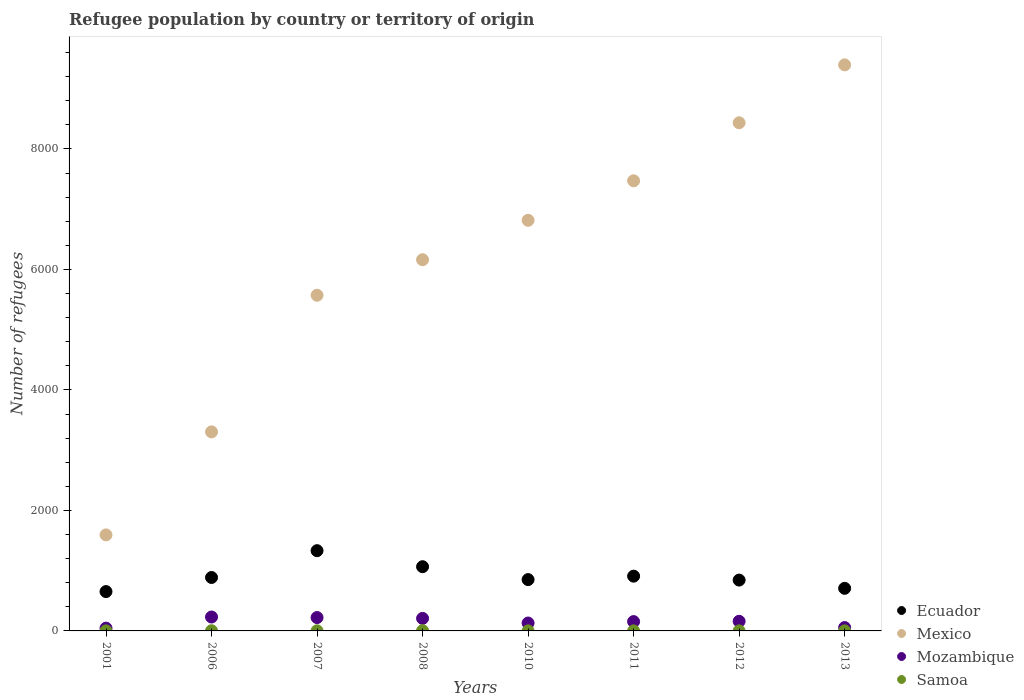What is the number of refugees in Mozambique in 2013?
Provide a succinct answer. 56. Across all years, what is the maximum number of refugees in Mozambique?
Offer a very short reply. 231. Across all years, what is the minimum number of refugees in Mozambique?
Give a very brief answer. 46. In which year was the number of refugees in Ecuador maximum?
Make the answer very short. 2007. In which year was the number of refugees in Samoa minimum?
Offer a terse response. 2001. What is the total number of refugees in Mexico in the graph?
Give a very brief answer. 4.88e+04. What is the difference between the number of refugees in Mexico in 2007 and that in 2013?
Your response must be concise. -3824. What is the difference between the number of refugees in Ecuador in 2013 and the number of refugees in Samoa in 2010?
Make the answer very short. 706. What is the average number of refugees in Ecuador per year?
Keep it short and to the point. 906.25. In the year 2007, what is the difference between the number of refugees in Mozambique and number of refugees in Mexico?
Make the answer very short. -5350. In how many years, is the number of refugees in Mexico greater than 2800?
Make the answer very short. 7. Is the number of refugees in Mexico in 2006 less than that in 2007?
Give a very brief answer. Yes. What is the difference between the highest and the second highest number of refugees in Mexico?
Your response must be concise. 961. What is the difference between the highest and the lowest number of refugees in Ecuador?
Make the answer very short. 679. Is the sum of the number of refugees in Samoa in 2001 and 2007 greater than the maximum number of refugees in Mexico across all years?
Make the answer very short. No. Does the graph contain any zero values?
Offer a very short reply. No. Does the graph contain grids?
Provide a short and direct response. No. How many legend labels are there?
Make the answer very short. 4. How are the legend labels stacked?
Your answer should be compact. Vertical. What is the title of the graph?
Your response must be concise. Refugee population by country or territory of origin. Does "Belarus" appear as one of the legend labels in the graph?
Offer a very short reply. No. What is the label or title of the Y-axis?
Offer a terse response. Number of refugees. What is the Number of refugees in Ecuador in 2001?
Provide a succinct answer. 653. What is the Number of refugees of Mexico in 2001?
Your answer should be compact. 1594. What is the Number of refugees in Mozambique in 2001?
Make the answer very short. 46. What is the Number of refugees in Samoa in 2001?
Provide a succinct answer. 1. What is the Number of refugees in Ecuador in 2006?
Offer a very short reply. 887. What is the Number of refugees of Mexico in 2006?
Provide a short and direct response. 3304. What is the Number of refugees of Mozambique in 2006?
Provide a short and direct response. 231. What is the Number of refugees of Ecuador in 2007?
Provide a short and direct response. 1332. What is the Number of refugees in Mexico in 2007?
Keep it short and to the point. 5572. What is the Number of refugees in Mozambique in 2007?
Provide a short and direct response. 222. What is the Number of refugees in Ecuador in 2008?
Your answer should be compact. 1066. What is the Number of refugees in Mexico in 2008?
Make the answer very short. 6162. What is the Number of refugees in Mozambique in 2008?
Your answer should be very brief. 208. What is the Number of refugees of Samoa in 2008?
Provide a short and direct response. 4. What is the Number of refugees in Ecuador in 2010?
Provide a short and direct response. 852. What is the Number of refugees of Mexico in 2010?
Keep it short and to the point. 6816. What is the Number of refugees of Mozambique in 2010?
Offer a terse response. 131. What is the Number of refugees in Ecuador in 2011?
Offer a terse response. 909. What is the Number of refugees in Mexico in 2011?
Make the answer very short. 7472. What is the Number of refugees of Mozambique in 2011?
Provide a succinct answer. 155. What is the Number of refugees of Samoa in 2011?
Ensure brevity in your answer.  1. What is the Number of refugees of Ecuador in 2012?
Provide a succinct answer. 844. What is the Number of refugees of Mexico in 2012?
Provide a succinct answer. 8435. What is the Number of refugees of Mozambique in 2012?
Your response must be concise. 160. What is the Number of refugees of Samoa in 2012?
Your response must be concise. 1. What is the Number of refugees in Ecuador in 2013?
Make the answer very short. 707. What is the Number of refugees of Mexico in 2013?
Provide a short and direct response. 9396. What is the Number of refugees of Mozambique in 2013?
Give a very brief answer. 56. Across all years, what is the maximum Number of refugees in Ecuador?
Your answer should be very brief. 1332. Across all years, what is the maximum Number of refugees in Mexico?
Your answer should be compact. 9396. Across all years, what is the maximum Number of refugees of Mozambique?
Give a very brief answer. 231. Across all years, what is the minimum Number of refugees of Ecuador?
Your answer should be very brief. 653. Across all years, what is the minimum Number of refugees of Mexico?
Make the answer very short. 1594. Across all years, what is the minimum Number of refugees in Samoa?
Provide a short and direct response. 1. What is the total Number of refugees of Ecuador in the graph?
Offer a terse response. 7250. What is the total Number of refugees in Mexico in the graph?
Provide a succinct answer. 4.88e+04. What is the total Number of refugees in Mozambique in the graph?
Ensure brevity in your answer.  1209. What is the difference between the Number of refugees of Ecuador in 2001 and that in 2006?
Your answer should be compact. -234. What is the difference between the Number of refugees of Mexico in 2001 and that in 2006?
Keep it short and to the point. -1710. What is the difference between the Number of refugees in Mozambique in 2001 and that in 2006?
Give a very brief answer. -185. What is the difference between the Number of refugees in Ecuador in 2001 and that in 2007?
Make the answer very short. -679. What is the difference between the Number of refugees in Mexico in 2001 and that in 2007?
Give a very brief answer. -3978. What is the difference between the Number of refugees in Mozambique in 2001 and that in 2007?
Keep it short and to the point. -176. What is the difference between the Number of refugees in Ecuador in 2001 and that in 2008?
Ensure brevity in your answer.  -413. What is the difference between the Number of refugees of Mexico in 2001 and that in 2008?
Make the answer very short. -4568. What is the difference between the Number of refugees of Mozambique in 2001 and that in 2008?
Keep it short and to the point. -162. What is the difference between the Number of refugees of Samoa in 2001 and that in 2008?
Your response must be concise. -3. What is the difference between the Number of refugees of Ecuador in 2001 and that in 2010?
Make the answer very short. -199. What is the difference between the Number of refugees in Mexico in 2001 and that in 2010?
Give a very brief answer. -5222. What is the difference between the Number of refugees in Mozambique in 2001 and that in 2010?
Your answer should be very brief. -85. What is the difference between the Number of refugees in Ecuador in 2001 and that in 2011?
Provide a short and direct response. -256. What is the difference between the Number of refugees of Mexico in 2001 and that in 2011?
Offer a very short reply. -5878. What is the difference between the Number of refugees in Mozambique in 2001 and that in 2011?
Your answer should be very brief. -109. What is the difference between the Number of refugees in Ecuador in 2001 and that in 2012?
Give a very brief answer. -191. What is the difference between the Number of refugees in Mexico in 2001 and that in 2012?
Your answer should be very brief. -6841. What is the difference between the Number of refugees in Mozambique in 2001 and that in 2012?
Keep it short and to the point. -114. What is the difference between the Number of refugees of Samoa in 2001 and that in 2012?
Give a very brief answer. 0. What is the difference between the Number of refugees of Ecuador in 2001 and that in 2013?
Ensure brevity in your answer.  -54. What is the difference between the Number of refugees in Mexico in 2001 and that in 2013?
Keep it short and to the point. -7802. What is the difference between the Number of refugees of Samoa in 2001 and that in 2013?
Your answer should be compact. 0. What is the difference between the Number of refugees in Ecuador in 2006 and that in 2007?
Keep it short and to the point. -445. What is the difference between the Number of refugees in Mexico in 2006 and that in 2007?
Offer a terse response. -2268. What is the difference between the Number of refugees in Ecuador in 2006 and that in 2008?
Your response must be concise. -179. What is the difference between the Number of refugees of Mexico in 2006 and that in 2008?
Keep it short and to the point. -2858. What is the difference between the Number of refugees in Mozambique in 2006 and that in 2008?
Ensure brevity in your answer.  23. What is the difference between the Number of refugees of Samoa in 2006 and that in 2008?
Give a very brief answer. -1. What is the difference between the Number of refugees of Ecuador in 2006 and that in 2010?
Offer a very short reply. 35. What is the difference between the Number of refugees of Mexico in 2006 and that in 2010?
Provide a short and direct response. -3512. What is the difference between the Number of refugees of Mozambique in 2006 and that in 2010?
Your answer should be compact. 100. What is the difference between the Number of refugees of Ecuador in 2006 and that in 2011?
Your answer should be compact. -22. What is the difference between the Number of refugees in Mexico in 2006 and that in 2011?
Give a very brief answer. -4168. What is the difference between the Number of refugees in Samoa in 2006 and that in 2011?
Ensure brevity in your answer.  2. What is the difference between the Number of refugees of Mexico in 2006 and that in 2012?
Your answer should be very brief. -5131. What is the difference between the Number of refugees of Samoa in 2006 and that in 2012?
Give a very brief answer. 2. What is the difference between the Number of refugees of Ecuador in 2006 and that in 2013?
Offer a very short reply. 180. What is the difference between the Number of refugees in Mexico in 2006 and that in 2013?
Make the answer very short. -6092. What is the difference between the Number of refugees in Mozambique in 2006 and that in 2013?
Make the answer very short. 175. What is the difference between the Number of refugees of Samoa in 2006 and that in 2013?
Make the answer very short. 2. What is the difference between the Number of refugees of Ecuador in 2007 and that in 2008?
Make the answer very short. 266. What is the difference between the Number of refugees of Mexico in 2007 and that in 2008?
Offer a very short reply. -590. What is the difference between the Number of refugees in Mozambique in 2007 and that in 2008?
Give a very brief answer. 14. What is the difference between the Number of refugees in Samoa in 2007 and that in 2008?
Provide a short and direct response. -2. What is the difference between the Number of refugees in Ecuador in 2007 and that in 2010?
Ensure brevity in your answer.  480. What is the difference between the Number of refugees of Mexico in 2007 and that in 2010?
Make the answer very short. -1244. What is the difference between the Number of refugees of Mozambique in 2007 and that in 2010?
Provide a succinct answer. 91. What is the difference between the Number of refugees of Ecuador in 2007 and that in 2011?
Your response must be concise. 423. What is the difference between the Number of refugees of Mexico in 2007 and that in 2011?
Ensure brevity in your answer.  -1900. What is the difference between the Number of refugees of Ecuador in 2007 and that in 2012?
Provide a succinct answer. 488. What is the difference between the Number of refugees of Mexico in 2007 and that in 2012?
Provide a succinct answer. -2863. What is the difference between the Number of refugees in Ecuador in 2007 and that in 2013?
Make the answer very short. 625. What is the difference between the Number of refugees of Mexico in 2007 and that in 2013?
Give a very brief answer. -3824. What is the difference between the Number of refugees of Mozambique in 2007 and that in 2013?
Your response must be concise. 166. What is the difference between the Number of refugees in Samoa in 2007 and that in 2013?
Provide a succinct answer. 1. What is the difference between the Number of refugees of Ecuador in 2008 and that in 2010?
Give a very brief answer. 214. What is the difference between the Number of refugees of Mexico in 2008 and that in 2010?
Your answer should be very brief. -654. What is the difference between the Number of refugees of Mozambique in 2008 and that in 2010?
Make the answer very short. 77. What is the difference between the Number of refugees in Ecuador in 2008 and that in 2011?
Offer a terse response. 157. What is the difference between the Number of refugees in Mexico in 2008 and that in 2011?
Offer a terse response. -1310. What is the difference between the Number of refugees of Ecuador in 2008 and that in 2012?
Provide a short and direct response. 222. What is the difference between the Number of refugees in Mexico in 2008 and that in 2012?
Ensure brevity in your answer.  -2273. What is the difference between the Number of refugees in Mozambique in 2008 and that in 2012?
Your answer should be very brief. 48. What is the difference between the Number of refugees in Samoa in 2008 and that in 2012?
Ensure brevity in your answer.  3. What is the difference between the Number of refugees of Ecuador in 2008 and that in 2013?
Provide a short and direct response. 359. What is the difference between the Number of refugees of Mexico in 2008 and that in 2013?
Your response must be concise. -3234. What is the difference between the Number of refugees in Mozambique in 2008 and that in 2013?
Offer a very short reply. 152. What is the difference between the Number of refugees in Samoa in 2008 and that in 2013?
Provide a succinct answer. 3. What is the difference between the Number of refugees of Ecuador in 2010 and that in 2011?
Your answer should be very brief. -57. What is the difference between the Number of refugees of Mexico in 2010 and that in 2011?
Ensure brevity in your answer.  -656. What is the difference between the Number of refugees of Mozambique in 2010 and that in 2011?
Your answer should be very brief. -24. What is the difference between the Number of refugees in Samoa in 2010 and that in 2011?
Provide a short and direct response. 0. What is the difference between the Number of refugees in Mexico in 2010 and that in 2012?
Your response must be concise. -1619. What is the difference between the Number of refugees in Mozambique in 2010 and that in 2012?
Keep it short and to the point. -29. What is the difference between the Number of refugees in Samoa in 2010 and that in 2012?
Provide a succinct answer. 0. What is the difference between the Number of refugees of Ecuador in 2010 and that in 2013?
Offer a very short reply. 145. What is the difference between the Number of refugees of Mexico in 2010 and that in 2013?
Provide a succinct answer. -2580. What is the difference between the Number of refugees of Mozambique in 2010 and that in 2013?
Offer a very short reply. 75. What is the difference between the Number of refugees in Ecuador in 2011 and that in 2012?
Your response must be concise. 65. What is the difference between the Number of refugees in Mexico in 2011 and that in 2012?
Give a very brief answer. -963. What is the difference between the Number of refugees of Ecuador in 2011 and that in 2013?
Your response must be concise. 202. What is the difference between the Number of refugees in Mexico in 2011 and that in 2013?
Your answer should be very brief. -1924. What is the difference between the Number of refugees in Ecuador in 2012 and that in 2013?
Your answer should be very brief. 137. What is the difference between the Number of refugees of Mexico in 2012 and that in 2013?
Ensure brevity in your answer.  -961. What is the difference between the Number of refugees in Mozambique in 2012 and that in 2013?
Your response must be concise. 104. What is the difference between the Number of refugees of Ecuador in 2001 and the Number of refugees of Mexico in 2006?
Your answer should be compact. -2651. What is the difference between the Number of refugees in Ecuador in 2001 and the Number of refugees in Mozambique in 2006?
Keep it short and to the point. 422. What is the difference between the Number of refugees of Ecuador in 2001 and the Number of refugees of Samoa in 2006?
Ensure brevity in your answer.  650. What is the difference between the Number of refugees in Mexico in 2001 and the Number of refugees in Mozambique in 2006?
Give a very brief answer. 1363. What is the difference between the Number of refugees in Mexico in 2001 and the Number of refugees in Samoa in 2006?
Provide a short and direct response. 1591. What is the difference between the Number of refugees of Mozambique in 2001 and the Number of refugees of Samoa in 2006?
Your answer should be very brief. 43. What is the difference between the Number of refugees in Ecuador in 2001 and the Number of refugees in Mexico in 2007?
Your answer should be compact. -4919. What is the difference between the Number of refugees in Ecuador in 2001 and the Number of refugees in Mozambique in 2007?
Offer a very short reply. 431. What is the difference between the Number of refugees of Ecuador in 2001 and the Number of refugees of Samoa in 2007?
Offer a very short reply. 651. What is the difference between the Number of refugees in Mexico in 2001 and the Number of refugees in Mozambique in 2007?
Your response must be concise. 1372. What is the difference between the Number of refugees of Mexico in 2001 and the Number of refugees of Samoa in 2007?
Provide a succinct answer. 1592. What is the difference between the Number of refugees of Mozambique in 2001 and the Number of refugees of Samoa in 2007?
Your response must be concise. 44. What is the difference between the Number of refugees in Ecuador in 2001 and the Number of refugees in Mexico in 2008?
Your answer should be compact. -5509. What is the difference between the Number of refugees in Ecuador in 2001 and the Number of refugees in Mozambique in 2008?
Ensure brevity in your answer.  445. What is the difference between the Number of refugees in Ecuador in 2001 and the Number of refugees in Samoa in 2008?
Your response must be concise. 649. What is the difference between the Number of refugees of Mexico in 2001 and the Number of refugees of Mozambique in 2008?
Provide a succinct answer. 1386. What is the difference between the Number of refugees in Mexico in 2001 and the Number of refugees in Samoa in 2008?
Your answer should be very brief. 1590. What is the difference between the Number of refugees in Mozambique in 2001 and the Number of refugees in Samoa in 2008?
Keep it short and to the point. 42. What is the difference between the Number of refugees in Ecuador in 2001 and the Number of refugees in Mexico in 2010?
Your answer should be very brief. -6163. What is the difference between the Number of refugees of Ecuador in 2001 and the Number of refugees of Mozambique in 2010?
Give a very brief answer. 522. What is the difference between the Number of refugees in Ecuador in 2001 and the Number of refugees in Samoa in 2010?
Provide a succinct answer. 652. What is the difference between the Number of refugees in Mexico in 2001 and the Number of refugees in Mozambique in 2010?
Offer a very short reply. 1463. What is the difference between the Number of refugees of Mexico in 2001 and the Number of refugees of Samoa in 2010?
Your answer should be compact. 1593. What is the difference between the Number of refugees of Ecuador in 2001 and the Number of refugees of Mexico in 2011?
Offer a terse response. -6819. What is the difference between the Number of refugees of Ecuador in 2001 and the Number of refugees of Mozambique in 2011?
Ensure brevity in your answer.  498. What is the difference between the Number of refugees of Ecuador in 2001 and the Number of refugees of Samoa in 2011?
Your answer should be compact. 652. What is the difference between the Number of refugees in Mexico in 2001 and the Number of refugees in Mozambique in 2011?
Offer a very short reply. 1439. What is the difference between the Number of refugees of Mexico in 2001 and the Number of refugees of Samoa in 2011?
Your response must be concise. 1593. What is the difference between the Number of refugees of Mozambique in 2001 and the Number of refugees of Samoa in 2011?
Provide a succinct answer. 45. What is the difference between the Number of refugees in Ecuador in 2001 and the Number of refugees in Mexico in 2012?
Offer a very short reply. -7782. What is the difference between the Number of refugees in Ecuador in 2001 and the Number of refugees in Mozambique in 2012?
Offer a terse response. 493. What is the difference between the Number of refugees of Ecuador in 2001 and the Number of refugees of Samoa in 2012?
Ensure brevity in your answer.  652. What is the difference between the Number of refugees in Mexico in 2001 and the Number of refugees in Mozambique in 2012?
Your response must be concise. 1434. What is the difference between the Number of refugees of Mexico in 2001 and the Number of refugees of Samoa in 2012?
Your answer should be very brief. 1593. What is the difference between the Number of refugees of Ecuador in 2001 and the Number of refugees of Mexico in 2013?
Provide a succinct answer. -8743. What is the difference between the Number of refugees in Ecuador in 2001 and the Number of refugees in Mozambique in 2013?
Provide a succinct answer. 597. What is the difference between the Number of refugees in Ecuador in 2001 and the Number of refugees in Samoa in 2013?
Your answer should be compact. 652. What is the difference between the Number of refugees of Mexico in 2001 and the Number of refugees of Mozambique in 2013?
Provide a short and direct response. 1538. What is the difference between the Number of refugees of Mexico in 2001 and the Number of refugees of Samoa in 2013?
Your answer should be very brief. 1593. What is the difference between the Number of refugees in Ecuador in 2006 and the Number of refugees in Mexico in 2007?
Keep it short and to the point. -4685. What is the difference between the Number of refugees of Ecuador in 2006 and the Number of refugees of Mozambique in 2007?
Give a very brief answer. 665. What is the difference between the Number of refugees in Ecuador in 2006 and the Number of refugees in Samoa in 2007?
Offer a very short reply. 885. What is the difference between the Number of refugees of Mexico in 2006 and the Number of refugees of Mozambique in 2007?
Offer a very short reply. 3082. What is the difference between the Number of refugees in Mexico in 2006 and the Number of refugees in Samoa in 2007?
Provide a succinct answer. 3302. What is the difference between the Number of refugees of Mozambique in 2006 and the Number of refugees of Samoa in 2007?
Keep it short and to the point. 229. What is the difference between the Number of refugees in Ecuador in 2006 and the Number of refugees in Mexico in 2008?
Provide a short and direct response. -5275. What is the difference between the Number of refugees in Ecuador in 2006 and the Number of refugees in Mozambique in 2008?
Your response must be concise. 679. What is the difference between the Number of refugees in Ecuador in 2006 and the Number of refugees in Samoa in 2008?
Give a very brief answer. 883. What is the difference between the Number of refugees in Mexico in 2006 and the Number of refugees in Mozambique in 2008?
Your answer should be compact. 3096. What is the difference between the Number of refugees in Mexico in 2006 and the Number of refugees in Samoa in 2008?
Ensure brevity in your answer.  3300. What is the difference between the Number of refugees of Mozambique in 2006 and the Number of refugees of Samoa in 2008?
Give a very brief answer. 227. What is the difference between the Number of refugees of Ecuador in 2006 and the Number of refugees of Mexico in 2010?
Make the answer very short. -5929. What is the difference between the Number of refugees of Ecuador in 2006 and the Number of refugees of Mozambique in 2010?
Offer a very short reply. 756. What is the difference between the Number of refugees in Ecuador in 2006 and the Number of refugees in Samoa in 2010?
Offer a terse response. 886. What is the difference between the Number of refugees of Mexico in 2006 and the Number of refugees of Mozambique in 2010?
Provide a succinct answer. 3173. What is the difference between the Number of refugees in Mexico in 2006 and the Number of refugees in Samoa in 2010?
Keep it short and to the point. 3303. What is the difference between the Number of refugees of Mozambique in 2006 and the Number of refugees of Samoa in 2010?
Give a very brief answer. 230. What is the difference between the Number of refugees in Ecuador in 2006 and the Number of refugees in Mexico in 2011?
Your answer should be very brief. -6585. What is the difference between the Number of refugees of Ecuador in 2006 and the Number of refugees of Mozambique in 2011?
Offer a terse response. 732. What is the difference between the Number of refugees in Ecuador in 2006 and the Number of refugees in Samoa in 2011?
Your response must be concise. 886. What is the difference between the Number of refugees in Mexico in 2006 and the Number of refugees in Mozambique in 2011?
Your answer should be compact. 3149. What is the difference between the Number of refugees of Mexico in 2006 and the Number of refugees of Samoa in 2011?
Keep it short and to the point. 3303. What is the difference between the Number of refugees of Mozambique in 2006 and the Number of refugees of Samoa in 2011?
Offer a very short reply. 230. What is the difference between the Number of refugees in Ecuador in 2006 and the Number of refugees in Mexico in 2012?
Provide a short and direct response. -7548. What is the difference between the Number of refugees of Ecuador in 2006 and the Number of refugees of Mozambique in 2012?
Provide a succinct answer. 727. What is the difference between the Number of refugees in Ecuador in 2006 and the Number of refugees in Samoa in 2012?
Offer a very short reply. 886. What is the difference between the Number of refugees in Mexico in 2006 and the Number of refugees in Mozambique in 2012?
Make the answer very short. 3144. What is the difference between the Number of refugees in Mexico in 2006 and the Number of refugees in Samoa in 2012?
Provide a succinct answer. 3303. What is the difference between the Number of refugees of Mozambique in 2006 and the Number of refugees of Samoa in 2012?
Give a very brief answer. 230. What is the difference between the Number of refugees of Ecuador in 2006 and the Number of refugees of Mexico in 2013?
Your response must be concise. -8509. What is the difference between the Number of refugees of Ecuador in 2006 and the Number of refugees of Mozambique in 2013?
Keep it short and to the point. 831. What is the difference between the Number of refugees in Ecuador in 2006 and the Number of refugees in Samoa in 2013?
Provide a succinct answer. 886. What is the difference between the Number of refugees in Mexico in 2006 and the Number of refugees in Mozambique in 2013?
Provide a succinct answer. 3248. What is the difference between the Number of refugees of Mexico in 2006 and the Number of refugees of Samoa in 2013?
Provide a succinct answer. 3303. What is the difference between the Number of refugees of Mozambique in 2006 and the Number of refugees of Samoa in 2013?
Your answer should be very brief. 230. What is the difference between the Number of refugees in Ecuador in 2007 and the Number of refugees in Mexico in 2008?
Provide a short and direct response. -4830. What is the difference between the Number of refugees in Ecuador in 2007 and the Number of refugees in Mozambique in 2008?
Your response must be concise. 1124. What is the difference between the Number of refugees of Ecuador in 2007 and the Number of refugees of Samoa in 2008?
Give a very brief answer. 1328. What is the difference between the Number of refugees of Mexico in 2007 and the Number of refugees of Mozambique in 2008?
Ensure brevity in your answer.  5364. What is the difference between the Number of refugees in Mexico in 2007 and the Number of refugees in Samoa in 2008?
Your answer should be very brief. 5568. What is the difference between the Number of refugees in Mozambique in 2007 and the Number of refugees in Samoa in 2008?
Make the answer very short. 218. What is the difference between the Number of refugees in Ecuador in 2007 and the Number of refugees in Mexico in 2010?
Provide a succinct answer. -5484. What is the difference between the Number of refugees in Ecuador in 2007 and the Number of refugees in Mozambique in 2010?
Offer a very short reply. 1201. What is the difference between the Number of refugees in Ecuador in 2007 and the Number of refugees in Samoa in 2010?
Give a very brief answer. 1331. What is the difference between the Number of refugees in Mexico in 2007 and the Number of refugees in Mozambique in 2010?
Provide a short and direct response. 5441. What is the difference between the Number of refugees in Mexico in 2007 and the Number of refugees in Samoa in 2010?
Provide a succinct answer. 5571. What is the difference between the Number of refugees of Mozambique in 2007 and the Number of refugees of Samoa in 2010?
Your answer should be compact. 221. What is the difference between the Number of refugees of Ecuador in 2007 and the Number of refugees of Mexico in 2011?
Keep it short and to the point. -6140. What is the difference between the Number of refugees of Ecuador in 2007 and the Number of refugees of Mozambique in 2011?
Provide a succinct answer. 1177. What is the difference between the Number of refugees in Ecuador in 2007 and the Number of refugees in Samoa in 2011?
Ensure brevity in your answer.  1331. What is the difference between the Number of refugees in Mexico in 2007 and the Number of refugees in Mozambique in 2011?
Give a very brief answer. 5417. What is the difference between the Number of refugees of Mexico in 2007 and the Number of refugees of Samoa in 2011?
Your response must be concise. 5571. What is the difference between the Number of refugees of Mozambique in 2007 and the Number of refugees of Samoa in 2011?
Provide a short and direct response. 221. What is the difference between the Number of refugees in Ecuador in 2007 and the Number of refugees in Mexico in 2012?
Your answer should be compact. -7103. What is the difference between the Number of refugees of Ecuador in 2007 and the Number of refugees of Mozambique in 2012?
Your response must be concise. 1172. What is the difference between the Number of refugees in Ecuador in 2007 and the Number of refugees in Samoa in 2012?
Provide a short and direct response. 1331. What is the difference between the Number of refugees of Mexico in 2007 and the Number of refugees of Mozambique in 2012?
Your answer should be very brief. 5412. What is the difference between the Number of refugees of Mexico in 2007 and the Number of refugees of Samoa in 2012?
Provide a succinct answer. 5571. What is the difference between the Number of refugees in Mozambique in 2007 and the Number of refugees in Samoa in 2012?
Your answer should be compact. 221. What is the difference between the Number of refugees of Ecuador in 2007 and the Number of refugees of Mexico in 2013?
Offer a terse response. -8064. What is the difference between the Number of refugees of Ecuador in 2007 and the Number of refugees of Mozambique in 2013?
Provide a succinct answer. 1276. What is the difference between the Number of refugees of Ecuador in 2007 and the Number of refugees of Samoa in 2013?
Offer a very short reply. 1331. What is the difference between the Number of refugees in Mexico in 2007 and the Number of refugees in Mozambique in 2013?
Your answer should be very brief. 5516. What is the difference between the Number of refugees of Mexico in 2007 and the Number of refugees of Samoa in 2013?
Provide a succinct answer. 5571. What is the difference between the Number of refugees of Mozambique in 2007 and the Number of refugees of Samoa in 2013?
Give a very brief answer. 221. What is the difference between the Number of refugees in Ecuador in 2008 and the Number of refugees in Mexico in 2010?
Provide a succinct answer. -5750. What is the difference between the Number of refugees of Ecuador in 2008 and the Number of refugees of Mozambique in 2010?
Your answer should be compact. 935. What is the difference between the Number of refugees of Ecuador in 2008 and the Number of refugees of Samoa in 2010?
Ensure brevity in your answer.  1065. What is the difference between the Number of refugees in Mexico in 2008 and the Number of refugees in Mozambique in 2010?
Your response must be concise. 6031. What is the difference between the Number of refugees of Mexico in 2008 and the Number of refugees of Samoa in 2010?
Offer a terse response. 6161. What is the difference between the Number of refugees of Mozambique in 2008 and the Number of refugees of Samoa in 2010?
Ensure brevity in your answer.  207. What is the difference between the Number of refugees in Ecuador in 2008 and the Number of refugees in Mexico in 2011?
Ensure brevity in your answer.  -6406. What is the difference between the Number of refugees of Ecuador in 2008 and the Number of refugees of Mozambique in 2011?
Offer a very short reply. 911. What is the difference between the Number of refugees of Ecuador in 2008 and the Number of refugees of Samoa in 2011?
Provide a succinct answer. 1065. What is the difference between the Number of refugees in Mexico in 2008 and the Number of refugees in Mozambique in 2011?
Keep it short and to the point. 6007. What is the difference between the Number of refugees in Mexico in 2008 and the Number of refugees in Samoa in 2011?
Offer a very short reply. 6161. What is the difference between the Number of refugees in Mozambique in 2008 and the Number of refugees in Samoa in 2011?
Your response must be concise. 207. What is the difference between the Number of refugees of Ecuador in 2008 and the Number of refugees of Mexico in 2012?
Ensure brevity in your answer.  -7369. What is the difference between the Number of refugees of Ecuador in 2008 and the Number of refugees of Mozambique in 2012?
Provide a short and direct response. 906. What is the difference between the Number of refugees of Ecuador in 2008 and the Number of refugees of Samoa in 2012?
Ensure brevity in your answer.  1065. What is the difference between the Number of refugees of Mexico in 2008 and the Number of refugees of Mozambique in 2012?
Provide a succinct answer. 6002. What is the difference between the Number of refugees of Mexico in 2008 and the Number of refugees of Samoa in 2012?
Offer a terse response. 6161. What is the difference between the Number of refugees in Mozambique in 2008 and the Number of refugees in Samoa in 2012?
Give a very brief answer. 207. What is the difference between the Number of refugees in Ecuador in 2008 and the Number of refugees in Mexico in 2013?
Offer a terse response. -8330. What is the difference between the Number of refugees of Ecuador in 2008 and the Number of refugees of Mozambique in 2013?
Provide a succinct answer. 1010. What is the difference between the Number of refugees of Ecuador in 2008 and the Number of refugees of Samoa in 2013?
Your answer should be compact. 1065. What is the difference between the Number of refugees of Mexico in 2008 and the Number of refugees of Mozambique in 2013?
Your answer should be compact. 6106. What is the difference between the Number of refugees of Mexico in 2008 and the Number of refugees of Samoa in 2013?
Your answer should be compact. 6161. What is the difference between the Number of refugees of Mozambique in 2008 and the Number of refugees of Samoa in 2013?
Offer a terse response. 207. What is the difference between the Number of refugees in Ecuador in 2010 and the Number of refugees in Mexico in 2011?
Provide a short and direct response. -6620. What is the difference between the Number of refugees in Ecuador in 2010 and the Number of refugees in Mozambique in 2011?
Your answer should be compact. 697. What is the difference between the Number of refugees of Ecuador in 2010 and the Number of refugees of Samoa in 2011?
Offer a terse response. 851. What is the difference between the Number of refugees of Mexico in 2010 and the Number of refugees of Mozambique in 2011?
Your response must be concise. 6661. What is the difference between the Number of refugees in Mexico in 2010 and the Number of refugees in Samoa in 2011?
Make the answer very short. 6815. What is the difference between the Number of refugees in Mozambique in 2010 and the Number of refugees in Samoa in 2011?
Make the answer very short. 130. What is the difference between the Number of refugees in Ecuador in 2010 and the Number of refugees in Mexico in 2012?
Ensure brevity in your answer.  -7583. What is the difference between the Number of refugees in Ecuador in 2010 and the Number of refugees in Mozambique in 2012?
Make the answer very short. 692. What is the difference between the Number of refugees in Ecuador in 2010 and the Number of refugees in Samoa in 2012?
Provide a succinct answer. 851. What is the difference between the Number of refugees of Mexico in 2010 and the Number of refugees of Mozambique in 2012?
Provide a succinct answer. 6656. What is the difference between the Number of refugees of Mexico in 2010 and the Number of refugees of Samoa in 2012?
Your answer should be very brief. 6815. What is the difference between the Number of refugees of Mozambique in 2010 and the Number of refugees of Samoa in 2012?
Ensure brevity in your answer.  130. What is the difference between the Number of refugees of Ecuador in 2010 and the Number of refugees of Mexico in 2013?
Keep it short and to the point. -8544. What is the difference between the Number of refugees in Ecuador in 2010 and the Number of refugees in Mozambique in 2013?
Provide a succinct answer. 796. What is the difference between the Number of refugees of Ecuador in 2010 and the Number of refugees of Samoa in 2013?
Ensure brevity in your answer.  851. What is the difference between the Number of refugees in Mexico in 2010 and the Number of refugees in Mozambique in 2013?
Ensure brevity in your answer.  6760. What is the difference between the Number of refugees in Mexico in 2010 and the Number of refugees in Samoa in 2013?
Make the answer very short. 6815. What is the difference between the Number of refugees in Mozambique in 2010 and the Number of refugees in Samoa in 2013?
Your response must be concise. 130. What is the difference between the Number of refugees of Ecuador in 2011 and the Number of refugees of Mexico in 2012?
Offer a very short reply. -7526. What is the difference between the Number of refugees in Ecuador in 2011 and the Number of refugees in Mozambique in 2012?
Offer a terse response. 749. What is the difference between the Number of refugees of Ecuador in 2011 and the Number of refugees of Samoa in 2012?
Offer a terse response. 908. What is the difference between the Number of refugees of Mexico in 2011 and the Number of refugees of Mozambique in 2012?
Offer a very short reply. 7312. What is the difference between the Number of refugees of Mexico in 2011 and the Number of refugees of Samoa in 2012?
Provide a short and direct response. 7471. What is the difference between the Number of refugees in Mozambique in 2011 and the Number of refugees in Samoa in 2012?
Offer a very short reply. 154. What is the difference between the Number of refugees in Ecuador in 2011 and the Number of refugees in Mexico in 2013?
Make the answer very short. -8487. What is the difference between the Number of refugees of Ecuador in 2011 and the Number of refugees of Mozambique in 2013?
Provide a short and direct response. 853. What is the difference between the Number of refugees in Ecuador in 2011 and the Number of refugees in Samoa in 2013?
Your response must be concise. 908. What is the difference between the Number of refugees in Mexico in 2011 and the Number of refugees in Mozambique in 2013?
Make the answer very short. 7416. What is the difference between the Number of refugees of Mexico in 2011 and the Number of refugees of Samoa in 2013?
Provide a short and direct response. 7471. What is the difference between the Number of refugees of Mozambique in 2011 and the Number of refugees of Samoa in 2013?
Offer a terse response. 154. What is the difference between the Number of refugees in Ecuador in 2012 and the Number of refugees in Mexico in 2013?
Your response must be concise. -8552. What is the difference between the Number of refugees of Ecuador in 2012 and the Number of refugees of Mozambique in 2013?
Your answer should be very brief. 788. What is the difference between the Number of refugees in Ecuador in 2012 and the Number of refugees in Samoa in 2013?
Make the answer very short. 843. What is the difference between the Number of refugees of Mexico in 2012 and the Number of refugees of Mozambique in 2013?
Your answer should be very brief. 8379. What is the difference between the Number of refugees of Mexico in 2012 and the Number of refugees of Samoa in 2013?
Your response must be concise. 8434. What is the difference between the Number of refugees in Mozambique in 2012 and the Number of refugees in Samoa in 2013?
Offer a terse response. 159. What is the average Number of refugees of Ecuador per year?
Ensure brevity in your answer.  906.25. What is the average Number of refugees of Mexico per year?
Offer a very short reply. 6093.88. What is the average Number of refugees in Mozambique per year?
Ensure brevity in your answer.  151.12. In the year 2001, what is the difference between the Number of refugees in Ecuador and Number of refugees in Mexico?
Your response must be concise. -941. In the year 2001, what is the difference between the Number of refugees in Ecuador and Number of refugees in Mozambique?
Your response must be concise. 607. In the year 2001, what is the difference between the Number of refugees in Ecuador and Number of refugees in Samoa?
Ensure brevity in your answer.  652. In the year 2001, what is the difference between the Number of refugees in Mexico and Number of refugees in Mozambique?
Ensure brevity in your answer.  1548. In the year 2001, what is the difference between the Number of refugees in Mexico and Number of refugees in Samoa?
Your response must be concise. 1593. In the year 2001, what is the difference between the Number of refugees in Mozambique and Number of refugees in Samoa?
Make the answer very short. 45. In the year 2006, what is the difference between the Number of refugees of Ecuador and Number of refugees of Mexico?
Give a very brief answer. -2417. In the year 2006, what is the difference between the Number of refugees in Ecuador and Number of refugees in Mozambique?
Your answer should be compact. 656. In the year 2006, what is the difference between the Number of refugees of Ecuador and Number of refugees of Samoa?
Offer a terse response. 884. In the year 2006, what is the difference between the Number of refugees of Mexico and Number of refugees of Mozambique?
Provide a short and direct response. 3073. In the year 2006, what is the difference between the Number of refugees in Mexico and Number of refugees in Samoa?
Your answer should be compact. 3301. In the year 2006, what is the difference between the Number of refugees of Mozambique and Number of refugees of Samoa?
Ensure brevity in your answer.  228. In the year 2007, what is the difference between the Number of refugees in Ecuador and Number of refugees in Mexico?
Offer a very short reply. -4240. In the year 2007, what is the difference between the Number of refugees of Ecuador and Number of refugees of Mozambique?
Give a very brief answer. 1110. In the year 2007, what is the difference between the Number of refugees in Ecuador and Number of refugees in Samoa?
Offer a terse response. 1330. In the year 2007, what is the difference between the Number of refugees of Mexico and Number of refugees of Mozambique?
Offer a terse response. 5350. In the year 2007, what is the difference between the Number of refugees in Mexico and Number of refugees in Samoa?
Make the answer very short. 5570. In the year 2007, what is the difference between the Number of refugees in Mozambique and Number of refugees in Samoa?
Offer a terse response. 220. In the year 2008, what is the difference between the Number of refugees of Ecuador and Number of refugees of Mexico?
Provide a succinct answer. -5096. In the year 2008, what is the difference between the Number of refugees of Ecuador and Number of refugees of Mozambique?
Offer a terse response. 858. In the year 2008, what is the difference between the Number of refugees of Ecuador and Number of refugees of Samoa?
Offer a very short reply. 1062. In the year 2008, what is the difference between the Number of refugees of Mexico and Number of refugees of Mozambique?
Keep it short and to the point. 5954. In the year 2008, what is the difference between the Number of refugees in Mexico and Number of refugees in Samoa?
Your response must be concise. 6158. In the year 2008, what is the difference between the Number of refugees of Mozambique and Number of refugees of Samoa?
Your answer should be very brief. 204. In the year 2010, what is the difference between the Number of refugees in Ecuador and Number of refugees in Mexico?
Provide a short and direct response. -5964. In the year 2010, what is the difference between the Number of refugees of Ecuador and Number of refugees of Mozambique?
Provide a short and direct response. 721. In the year 2010, what is the difference between the Number of refugees in Ecuador and Number of refugees in Samoa?
Ensure brevity in your answer.  851. In the year 2010, what is the difference between the Number of refugees of Mexico and Number of refugees of Mozambique?
Offer a terse response. 6685. In the year 2010, what is the difference between the Number of refugees in Mexico and Number of refugees in Samoa?
Your answer should be compact. 6815. In the year 2010, what is the difference between the Number of refugees in Mozambique and Number of refugees in Samoa?
Provide a succinct answer. 130. In the year 2011, what is the difference between the Number of refugees in Ecuador and Number of refugees in Mexico?
Offer a terse response. -6563. In the year 2011, what is the difference between the Number of refugees of Ecuador and Number of refugees of Mozambique?
Your answer should be very brief. 754. In the year 2011, what is the difference between the Number of refugees in Ecuador and Number of refugees in Samoa?
Keep it short and to the point. 908. In the year 2011, what is the difference between the Number of refugees of Mexico and Number of refugees of Mozambique?
Provide a succinct answer. 7317. In the year 2011, what is the difference between the Number of refugees in Mexico and Number of refugees in Samoa?
Your answer should be compact. 7471. In the year 2011, what is the difference between the Number of refugees of Mozambique and Number of refugees of Samoa?
Keep it short and to the point. 154. In the year 2012, what is the difference between the Number of refugees of Ecuador and Number of refugees of Mexico?
Provide a short and direct response. -7591. In the year 2012, what is the difference between the Number of refugees of Ecuador and Number of refugees of Mozambique?
Offer a very short reply. 684. In the year 2012, what is the difference between the Number of refugees of Ecuador and Number of refugees of Samoa?
Offer a very short reply. 843. In the year 2012, what is the difference between the Number of refugees in Mexico and Number of refugees in Mozambique?
Your answer should be very brief. 8275. In the year 2012, what is the difference between the Number of refugees of Mexico and Number of refugees of Samoa?
Provide a succinct answer. 8434. In the year 2012, what is the difference between the Number of refugees in Mozambique and Number of refugees in Samoa?
Offer a terse response. 159. In the year 2013, what is the difference between the Number of refugees in Ecuador and Number of refugees in Mexico?
Ensure brevity in your answer.  -8689. In the year 2013, what is the difference between the Number of refugees in Ecuador and Number of refugees in Mozambique?
Keep it short and to the point. 651. In the year 2013, what is the difference between the Number of refugees of Ecuador and Number of refugees of Samoa?
Offer a terse response. 706. In the year 2013, what is the difference between the Number of refugees in Mexico and Number of refugees in Mozambique?
Provide a short and direct response. 9340. In the year 2013, what is the difference between the Number of refugees in Mexico and Number of refugees in Samoa?
Make the answer very short. 9395. What is the ratio of the Number of refugees in Ecuador in 2001 to that in 2006?
Your answer should be compact. 0.74. What is the ratio of the Number of refugees of Mexico in 2001 to that in 2006?
Provide a short and direct response. 0.48. What is the ratio of the Number of refugees of Mozambique in 2001 to that in 2006?
Keep it short and to the point. 0.2. What is the ratio of the Number of refugees of Samoa in 2001 to that in 2006?
Your answer should be very brief. 0.33. What is the ratio of the Number of refugees in Ecuador in 2001 to that in 2007?
Ensure brevity in your answer.  0.49. What is the ratio of the Number of refugees in Mexico in 2001 to that in 2007?
Provide a short and direct response. 0.29. What is the ratio of the Number of refugees of Mozambique in 2001 to that in 2007?
Ensure brevity in your answer.  0.21. What is the ratio of the Number of refugees of Samoa in 2001 to that in 2007?
Offer a terse response. 0.5. What is the ratio of the Number of refugees of Ecuador in 2001 to that in 2008?
Offer a very short reply. 0.61. What is the ratio of the Number of refugees of Mexico in 2001 to that in 2008?
Offer a terse response. 0.26. What is the ratio of the Number of refugees of Mozambique in 2001 to that in 2008?
Offer a terse response. 0.22. What is the ratio of the Number of refugees in Samoa in 2001 to that in 2008?
Offer a terse response. 0.25. What is the ratio of the Number of refugees in Ecuador in 2001 to that in 2010?
Your answer should be compact. 0.77. What is the ratio of the Number of refugees of Mexico in 2001 to that in 2010?
Offer a very short reply. 0.23. What is the ratio of the Number of refugees of Mozambique in 2001 to that in 2010?
Provide a short and direct response. 0.35. What is the ratio of the Number of refugees in Ecuador in 2001 to that in 2011?
Your answer should be compact. 0.72. What is the ratio of the Number of refugees of Mexico in 2001 to that in 2011?
Offer a very short reply. 0.21. What is the ratio of the Number of refugees of Mozambique in 2001 to that in 2011?
Offer a terse response. 0.3. What is the ratio of the Number of refugees in Ecuador in 2001 to that in 2012?
Your response must be concise. 0.77. What is the ratio of the Number of refugees in Mexico in 2001 to that in 2012?
Give a very brief answer. 0.19. What is the ratio of the Number of refugees in Mozambique in 2001 to that in 2012?
Provide a succinct answer. 0.29. What is the ratio of the Number of refugees of Ecuador in 2001 to that in 2013?
Your answer should be compact. 0.92. What is the ratio of the Number of refugees of Mexico in 2001 to that in 2013?
Offer a very short reply. 0.17. What is the ratio of the Number of refugees of Mozambique in 2001 to that in 2013?
Offer a very short reply. 0.82. What is the ratio of the Number of refugees in Samoa in 2001 to that in 2013?
Make the answer very short. 1. What is the ratio of the Number of refugees of Ecuador in 2006 to that in 2007?
Keep it short and to the point. 0.67. What is the ratio of the Number of refugees of Mexico in 2006 to that in 2007?
Provide a short and direct response. 0.59. What is the ratio of the Number of refugees in Mozambique in 2006 to that in 2007?
Make the answer very short. 1.04. What is the ratio of the Number of refugees of Samoa in 2006 to that in 2007?
Make the answer very short. 1.5. What is the ratio of the Number of refugees in Ecuador in 2006 to that in 2008?
Make the answer very short. 0.83. What is the ratio of the Number of refugees of Mexico in 2006 to that in 2008?
Offer a very short reply. 0.54. What is the ratio of the Number of refugees of Mozambique in 2006 to that in 2008?
Offer a terse response. 1.11. What is the ratio of the Number of refugees of Samoa in 2006 to that in 2008?
Offer a terse response. 0.75. What is the ratio of the Number of refugees of Ecuador in 2006 to that in 2010?
Keep it short and to the point. 1.04. What is the ratio of the Number of refugees in Mexico in 2006 to that in 2010?
Your answer should be compact. 0.48. What is the ratio of the Number of refugees of Mozambique in 2006 to that in 2010?
Give a very brief answer. 1.76. What is the ratio of the Number of refugees of Samoa in 2006 to that in 2010?
Your response must be concise. 3. What is the ratio of the Number of refugees of Ecuador in 2006 to that in 2011?
Provide a succinct answer. 0.98. What is the ratio of the Number of refugees in Mexico in 2006 to that in 2011?
Keep it short and to the point. 0.44. What is the ratio of the Number of refugees in Mozambique in 2006 to that in 2011?
Give a very brief answer. 1.49. What is the ratio of the Number of refugees of Samoa in 2006 to that in 2011?
Provide a short and direct response. 3. What is the ratio of the Number of refugees in Ecuador in 2006 to that in 2012?
Your answer should be compact. 1.05. What is the ratio of the Number of refugees in Mexico in 2006 to that in 2012?
Keep it short and to the point. 0.39. What is the ratio of the Number of refugees of Mozambique in 2006 to that in 2012?
Provide a succinct answer. 1.44. What is the ratio of the Number of refugees in Samoa in 2006 to that in 2012?
Offer a terse response. 3. What is the ratio of the Number of refugees in Ecuador in 2006 to that in 2013?
Ensure brevity in your answer.  1.25. What is the ratio of the Number of refugees in Mexico in 2006 to that in 2013?
Your response must be concise. 0.35. What is the ratio of the Number of refugees in Mozambique in 2006 to that in 2013?
Give a very brief answer. 4.12. What is the ratio of the Number of refugees of Ecuador in 2007 to that in 2008?
Your answer should be compact. 1.25. What is the ratio of the Number of refugees of Mexico in 2007 to that in 2008?
Your answer should be very brief. 0.9. What is the ratio of the Number of refugees in Mozambique in 2007 to that in 2008?
Offer a terse response. 1.07. What is the ratio of the Number of refugees in Ecuador in 2007 to that in 2010?
Ensure brevity in your answer.  1.56. What is the ratio of the Number of refugees in Mexico in 2007 to that in 2010?
Ensure brevity in your answer.  0.82. What is the ratio of the Number of refugees in Mozambique in 2007 to that in 2010?
Ensure brevity in your answer.  1.69. What is the ratio of the Number of refugees in Samoa in 2007 to that in 2010?
Your response must be concise. 2. What is the ratio of the Number of refugees of Ecuador in 2007 to that in 2011?
Provide a succinct answer. 1.47. What is the ratio of the Number of refugees in Mexico in 2007 to that in 2011?
Your answer should be compact. 0.75. What is the ratio of the Number of refugees in Mozambique in 2007 to that in 2011?
Keep it short and to the point. 1.43. What is the ratio of the Number of refugees of Ecuador in 2007 to that in 2012?
Ensure brevity in your answer.  1.58. What is the ratio of the Number of refugees in Mexico in 2007 to that in 2012?
Your response must be concise. 0.66. What is the ratio of the Number of refugees in Mozambique in 2007 to that in 2012?
Ensure brevity in your answer.  1.39. What is the ratio of the Number of refugees in Samoa in 2007 to that in 2012?
Your response must be concise. 2. What is the ratio of the Number of refugees in Ecuador in 2007 to that in 2013?
Make the answer very short. 1.88. What is the ratio of the Number of refugees in Mexico in 2007 to that in 2013?
Keep it short and to the point. 0.59. What is the ratio of the Number of refugees of Mozambique in 2007 to that in 2013?
Keep it short and to the point. 3.96. What is the ratio of the Number of refugees in Samoa in 2007 to that in 2013?
Provide a succinct answer. 2. What is the ratio of the Number of refugees in Ecuador in 2008 to that in 2010?
Offer a very short reply. 1.25. What is the ratio of the Number of refugees of Mexico in 2008 to that in 2010?
Keep it short and to the point. 0.9. What is the ratio of the Number of refugees of Mozambique in 2008 to that in 2010?
Keep it short and to the point. 1.59. What is the ratio of the Number of refugees of Ecuador in 2008 to that in 2011?
Your answer should be compact. 1.17. What is the ratio of the Number of refugees in Mexico in 2008 to that in 2011?
Your response must be concise. 0.82. What is the ratio of the Number of refugees in Mozambique in 2008 to that in 2011?
Keep it short and to the point. 1.34. What is the ratio of the Number of refugees of Ecuador in 2008 to that in 2012?
Give a very brief answer. 1.26. What is the ratio of the Number of refugees of Mexico in 2008 to that in 2012?
Provide a succinct answer. 0.73. What is the ratio of the Number of refugees of Mozambique in 2008 to that in 2012?
Keep it short and to the point. 1.3. What is the ratio of the Number of refugees of Samoa in 2008 to that in 2012?
Provide a succinct answer. 4. What is the ratio of the Number of refugees in Ecuador in 2008 to that in 2013?
Provide a short and direct response. 1.51. What is the ratio of the Number of refugees of Mexico in 2008 to that in 2013?
Your answer should be compact. 0.66. What is the ratio of the Number of refugees of Mozambique in 2008 to that in 2013?
Provide a short and direct response. 3.71. What is the ratio of the Number of refugees in Samoa in 2008 to that in 2013?
Ensure brevity in your answer.  4. What is the ratio of the Number of refugees in Ecuador in 2010 to that in 2011?
Ensure brevity in your answer.  0.94. What is the ratio of the Number of refugees of Mexico in 2010 to that in 2011?
Offer a very short reply. 0.91. What is the ratio of the Number of refugees in Mozambique in 2010 to that in 2011?
Your answer should be very brief. 0.85. What is the ratio of the Number of refugees of Samoa in 2010 to that in 2011?
Offer a very short reply. 1. What is the ratio of the Number of refugees of Ecuador in 2010 to that in 2012?
Give a very brief answer. 1.01. What is the ratio of the Number of refugees in Mexico in 2010 to that in 2012?
Provide a short and direct response. 0.81. What is the ratio of the Number of refugees of Mozambique in 2010 to that in 2012?
Your answer should be compact. 0.82. What is the ratio of the Number of refugees in Ecuador in 2010 to that in 2013?
Provide a succinct answer. 1.21. What is the ratio of the Number of refugees in Mexico in 2010 to that in 2013?
Your answer should be very brief. 0.73. What is the ratio of the Number of refugees of Mozambique in 2010 to that in 2013?
Give a very brief answer. 2.34. What is the ratio of the Number of refugees in Samoa in 2010 to that in 2013?
Give a very brief answer. 1. What is the ratio of the Number of refugees of Ecuador in 2011 to that in 2012?
Your response must be concise. 1.08. What is the ratio of the Number of refugees in Mexico in 2011 to that in 2012?
Provide a succinct answer. 0.89. What is the ratio of the Number of refugees of Mozambique in 2011 to that in 2012?
Your answer should be compact. 0.97. What is the ratio of the Number of refugees of Mexico in 2011 to that in 2013?
Offer a terse response. 0.8. What is the ratio of the Number of refugees of Mozambique in 2011 to that in 2013?
Offer a terse response. 2.77. What is the ratio of the Number of refugees of Samoa in 2011 to that in 2013?
Ensure brevity in your answer.  1. What is the ratio of the Number of refugees of Ecuador in 2012 to that in 2013?
Ensure brevity in your answer.  1.19. What is the ratio of the Number of refugees in Mexico in 2012 to that in 2013?
Keep it short and to the point. 0.9. What is the ratio of the Number of refugees of Mozambique in 2012 to that in 2013?
Offer a very short reply. 2.86. What is the difference between the highest and the second highest Number of refugees of Ecuador?
Your answer should be very brief. 266. What is the difference between the highest and the second highest Number of refugees of Mexico?
Give a very brief answer. 961. What is the difference between the highest and the second highest Number of refugees in Mozambique?
Offer a terse response. 9. What is the difference between the highest and the second highest Number of refugees of Samoa?
Provide a short and direct response. 1. What is the difference between the highest and the lowest Number of refugees of Ecuador?
Offer a very short reply. 679. What is the difference between the highest and the lowest Number of refugees in Mexico?
Your answer should be compact. 7802. What is the difference between the highest and the lowest Number of refugees in Mozambique?
Give a very brief answer. 185. 